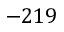Convert formula to latex. <formula><loc_0><loc_0><loc_500><loc_500>- 2 1 9</formula> 